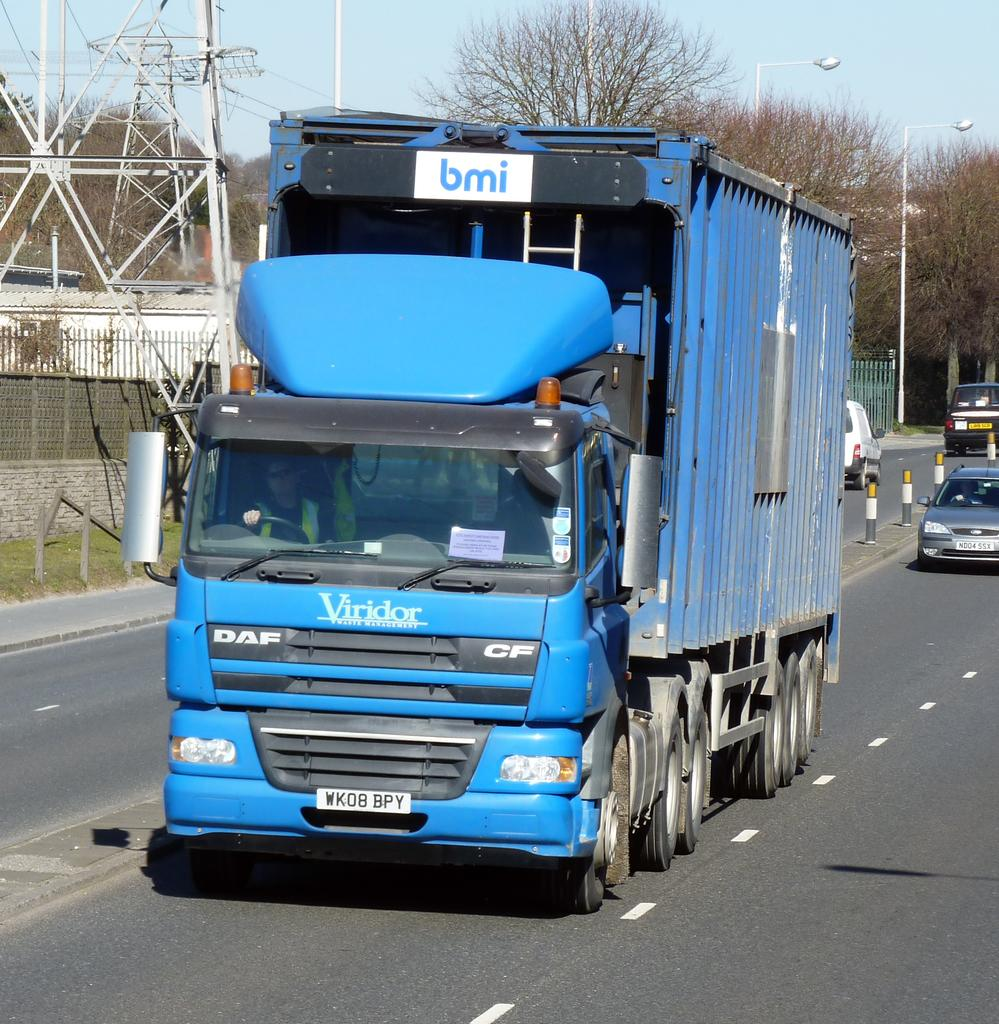What is the main subject of the image? The main subject of the image is a truck. What is the truck doing in the image? The truck is moving on a road in the image. What can be seen in the background of the image? There are trees visible in the image. Are there any other vehicles in the image besides the truck? Yes, there are vehicles in the image. What type of lighting is present in the image? Pole lights are present in the image. Can you tell me how many planes are flying above the truck in the image? There are no planes visible in the image; it only features a truck moving on a road with trees, vehicles, and pole lights present. 